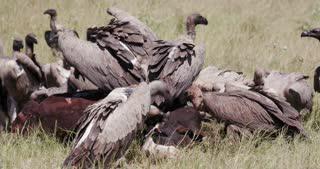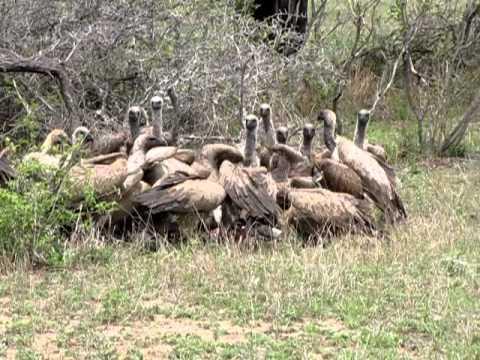The first image is the image on the left, the second image is the image on the right. Analyze the images presented: Is the assertion "In one of the images, the carrion birds are NOT eating anything at the moment." valid? Answer yes or no. Yes. The first image is the image on the left, the second image is the image on the right. Evaluate the accuracy of this statement regarding the images: "There are at least eight vultures eating a dead animal who is horns are visible.". Is it true? Answer yes or no. No. 